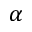Convert formula to latex. <formula><loc_0><loc_0><loc_500><loc_500>\alpha</formula> 